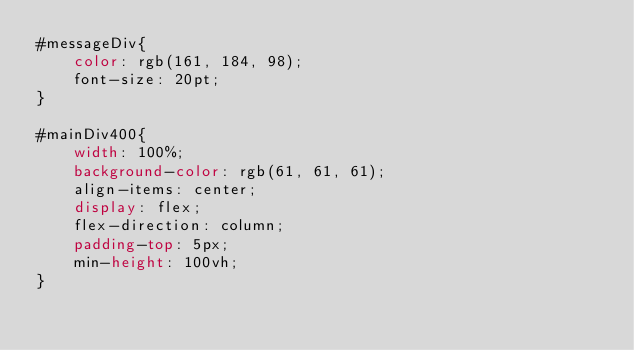Convert code to text. <code><loc_0><loc_0><loc_500><loc_500><_CSS_>#messageDiv{
    color: rgb(161, 184, 98);
    font-size: 20pt;
}

#mainDiv400{
    width: 100%;
    background-color: rgb(61, 61, 61);
    align-items: center;
    display: flex;
    flex-direction: column;
    padding-top: 5px;
    min-height: 100vh;
}
</code> 